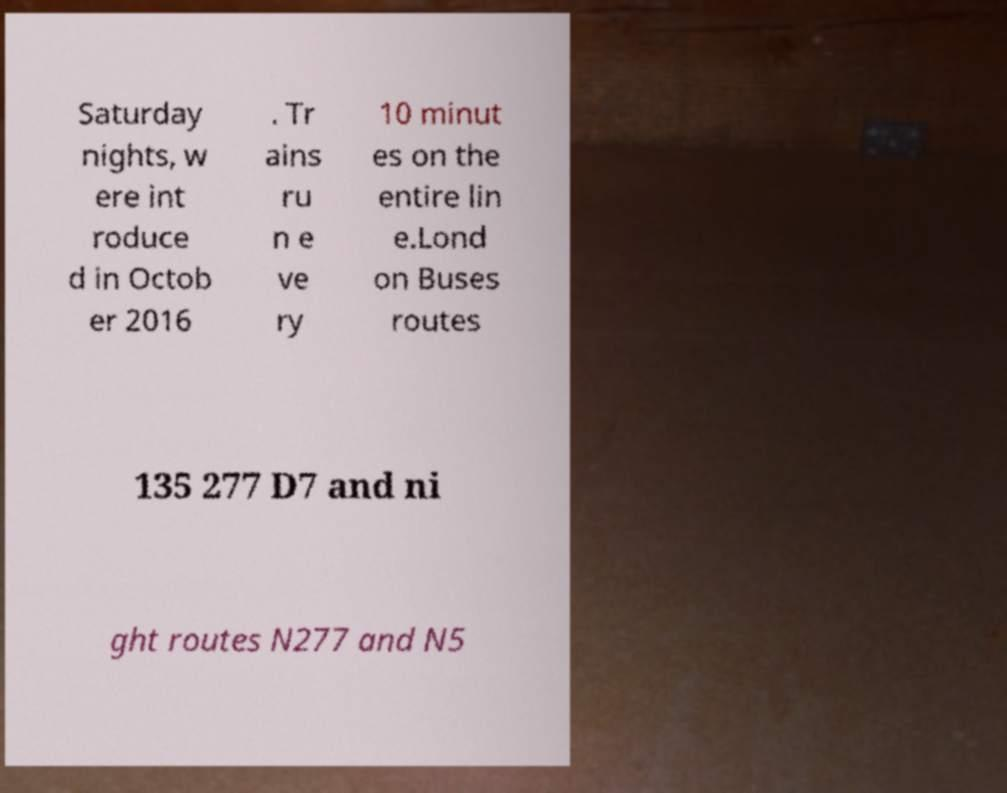What messages or text are displayed in this image? I need them in a readable, typed format. Saturday nights, w ere int roduce d in Octob er 2016 . Tr ains ru n e ve ry 10 minut es on the entire lin e.Lond on Buses routes 135 277 D7 and ni ght routes N277 and N5 